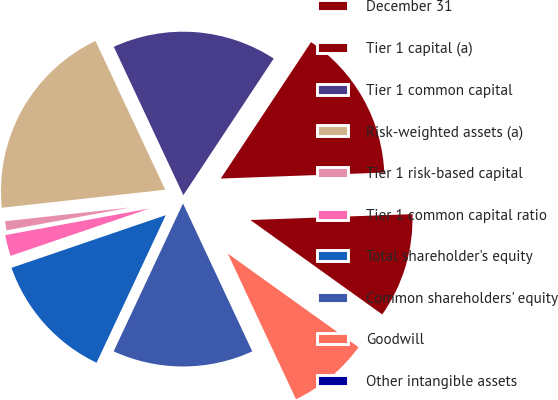<chart> <loc_0><loc_0><loc_500><loc_500><pie_chart><fcel>December 31<fcel>Tier 1 capital (a)<fcel>Tier 1 common capital<fcel>Risk-weighted assets (a)<fcel>Tier 1 risk-based capital<fcel>Tier 1 common capital ratio<fcel>Total shareholder's equity<fcel>Common shareholders' equity<fcel>Goodwill<fcel>Other intangible assets<nl><fcel>10.47%<fcel>15.12%<fcel>16.28%<fcel>19.77%<fcel>1.16%<fcel>2.33%<fcel>12.79%<fcel>13.95%<fcel>8.14%<fcel>0.0%<nl></chart> 